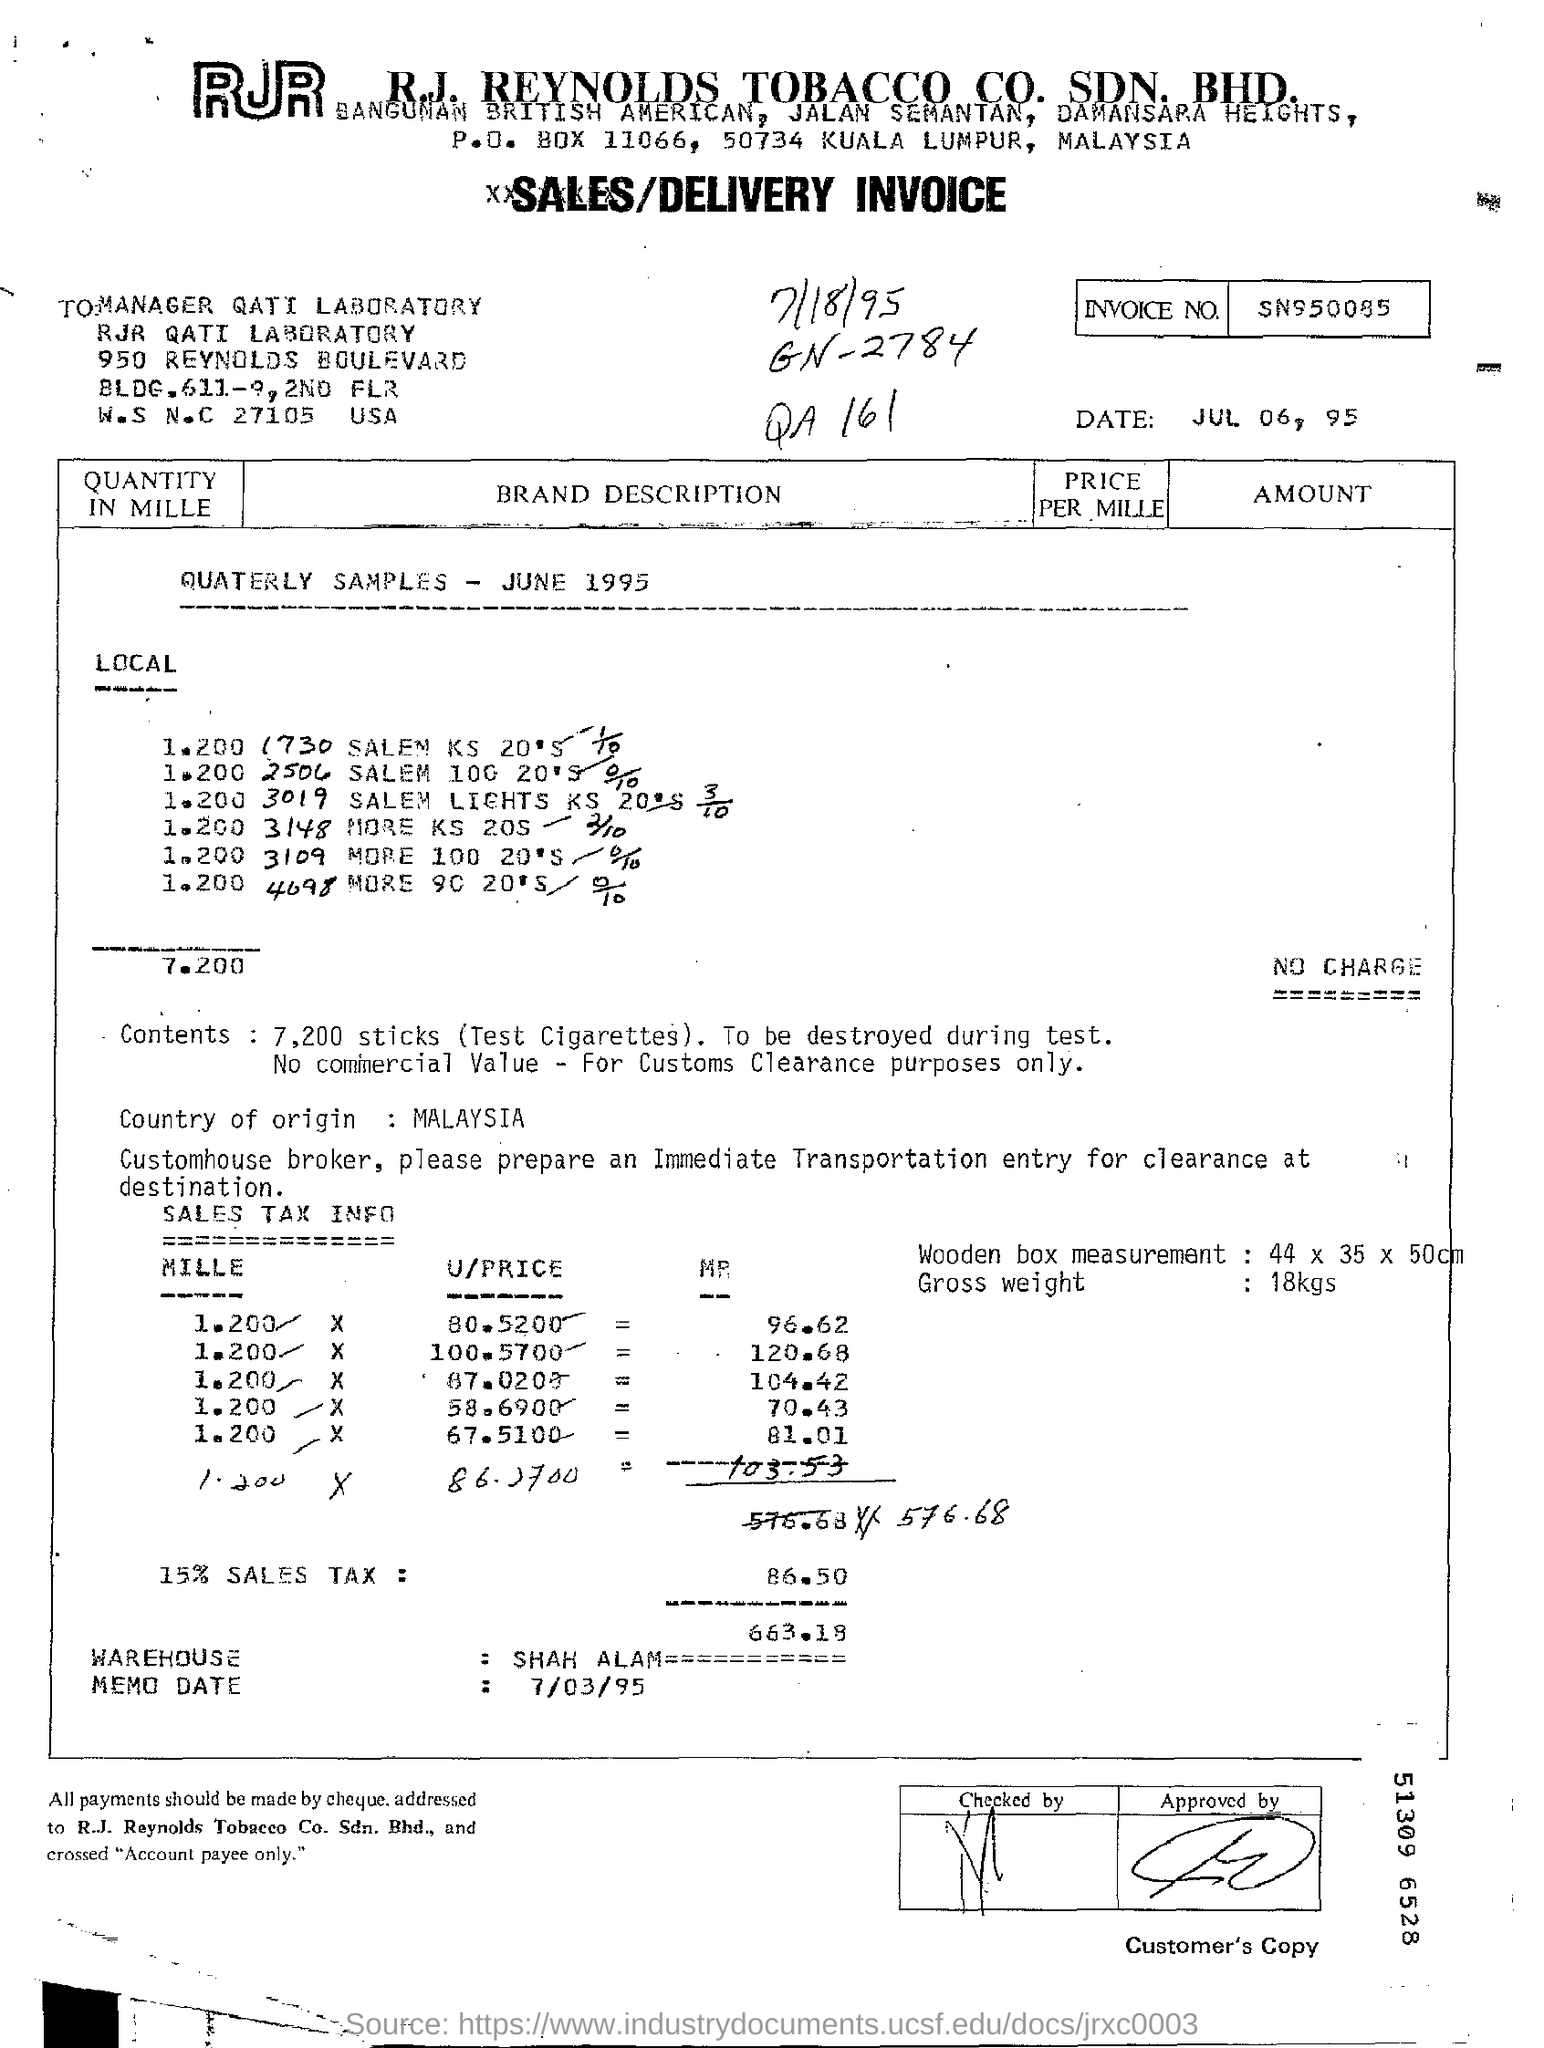What is the Invoice Number ?
Ensure brevity in your answer.  SN950085. What date mentioned in the below the invoice number ?
Provide a succinct answer. Jul 06, 95. What is GN Number ?
Provide a short and direct response. 2784. What is P.O. Box Number ?
Ensure brevity in your answer.  11066. What is the Company Name ?
Make the answer very short. R.J. REYNOLDS. What is the Memo Date ?
Provide a succinct answer. 7/03/95. Which is the coutry of origin?
Provide a short and direct response. Malaysia. What is the sales tax percentage?
Make the answer very short. 15%. How many cigarettes are there in the shipment?
Make the answer very short. 7,200. What is the gross weight of the shipment?
Give a very brief answer. 18kgs. 